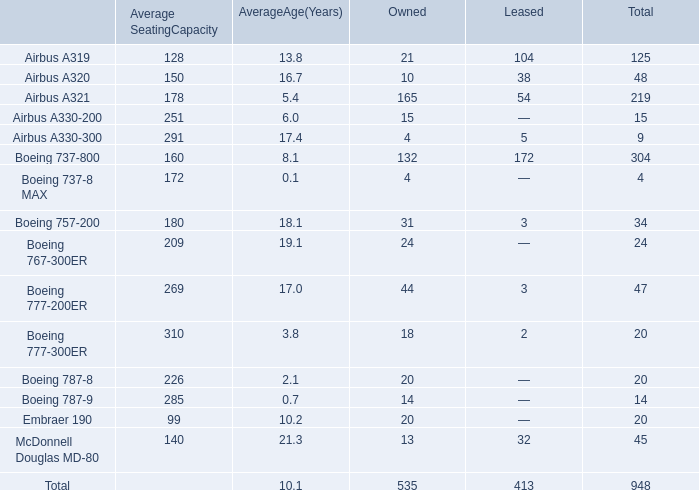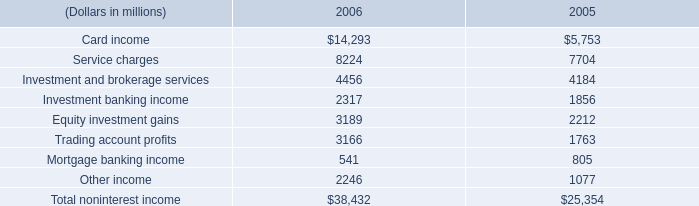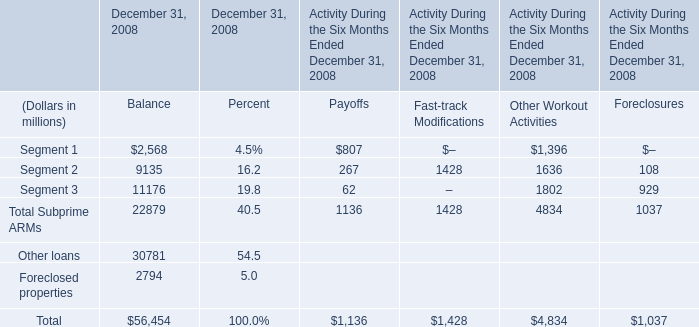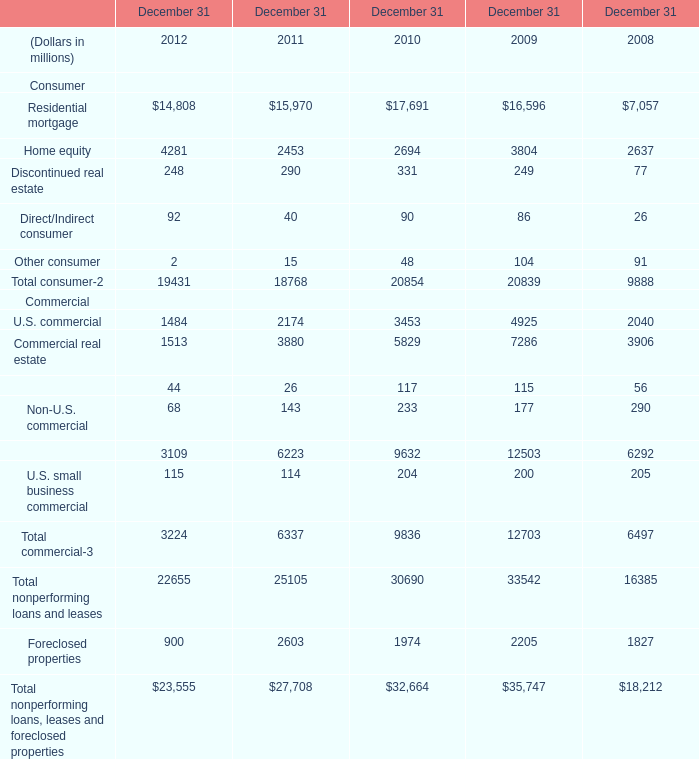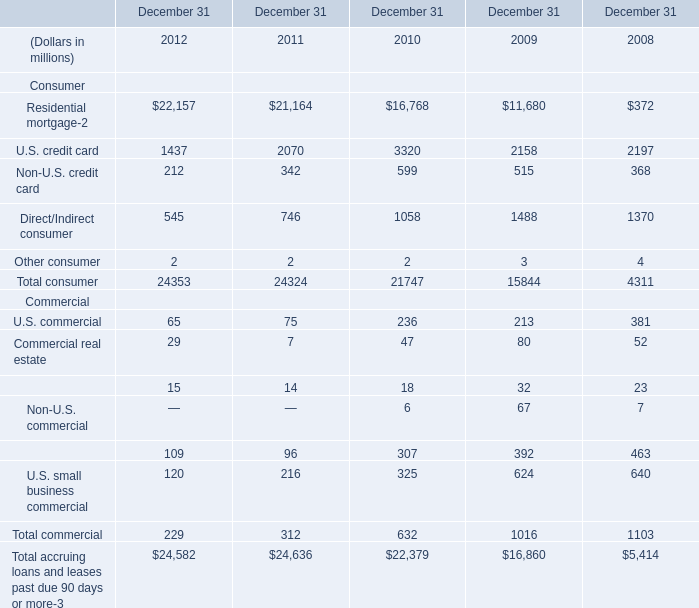What's the sum of Investment and brokerage services of 2006, Residential mortgage of December 31 2011, and Commercial real estate Commercial of December 31 2010 ? 
Computations: ((4456.0 + 15970.0) + 5829.0)
Answer: 26255.0. 